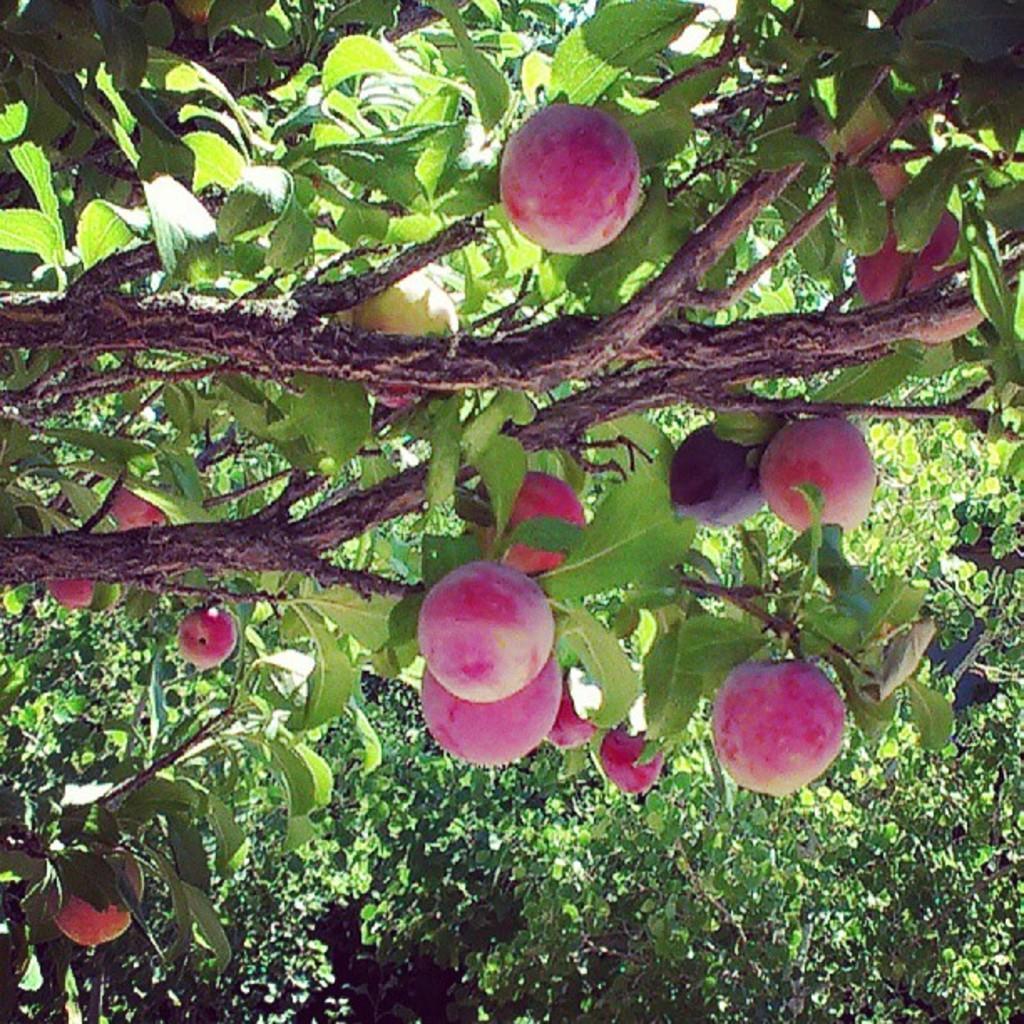Describe this image in one or two sentences. In this image I can see a tree which is green and brown in color and to it I can see few fruits which are pink and red in color. 